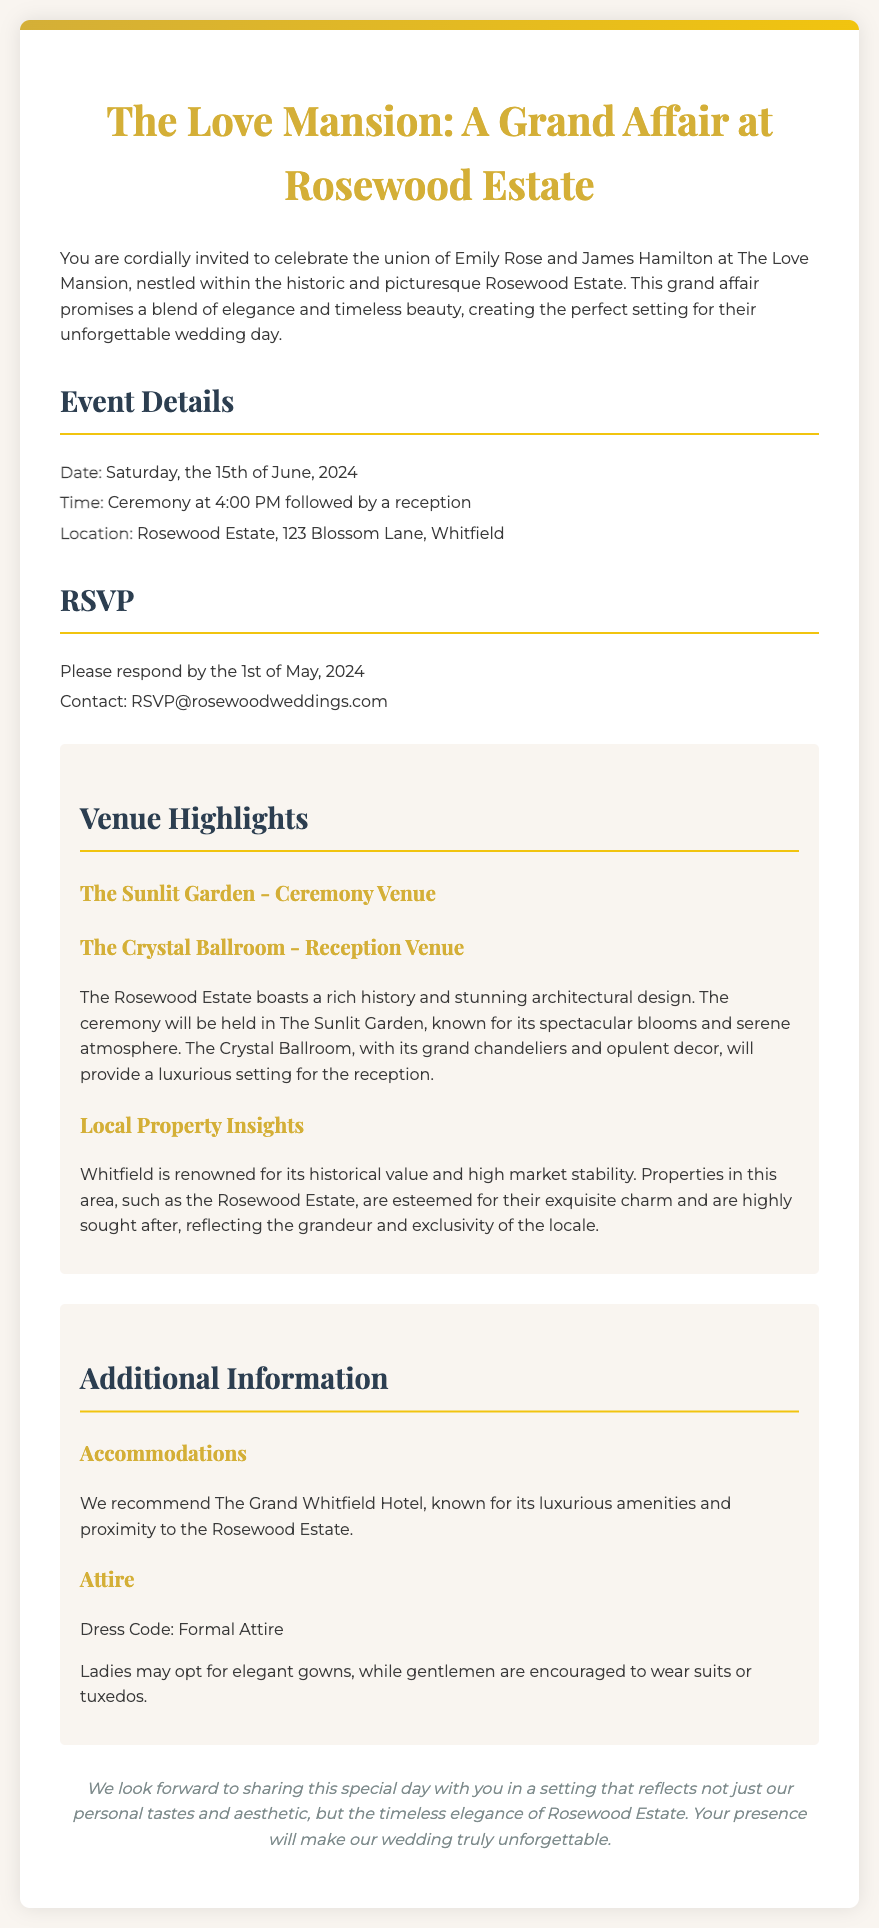What is the date of the wedding? The date of the wedding is explicitly stated in the document.
Answer: Saturday, the 15th of June, 2024 What time does the ceremony start? The document specifies the start time of the ceremony.
Answer: 4:00 PM Who are the couple getting married? The names of the couple are mentioned at the beginning of the invitation.
Answer: Emily Rose and James Hamilton Where is the wedding ceremony taking place? The location of the ceremony is indicated in the event details section.
Answer: Rosewood Estate, 123 Blossom Lane, Whitfield What is the RSVP deadline? The deadline for RSVPs is provided in the invitation.
Answer: 1st of May, 2024 What type of attire is requested? The document includes a section regarding dress code for the guests.
Answer: Formal Attire What are the names of the two main venues mentioned? The invitation highlights specific venues for the ceremony and reception.
Answer: The Sunlit Garden and The Crystal Ballroom Which hotel is recommended for accommodations? Accommodation suggestions are given in the additional information section.
Answer: The Grand Whitfield Hotel What is highlighted about the local property market? The document discusses insights regarding the local real estate market.
Answer: High market stability 